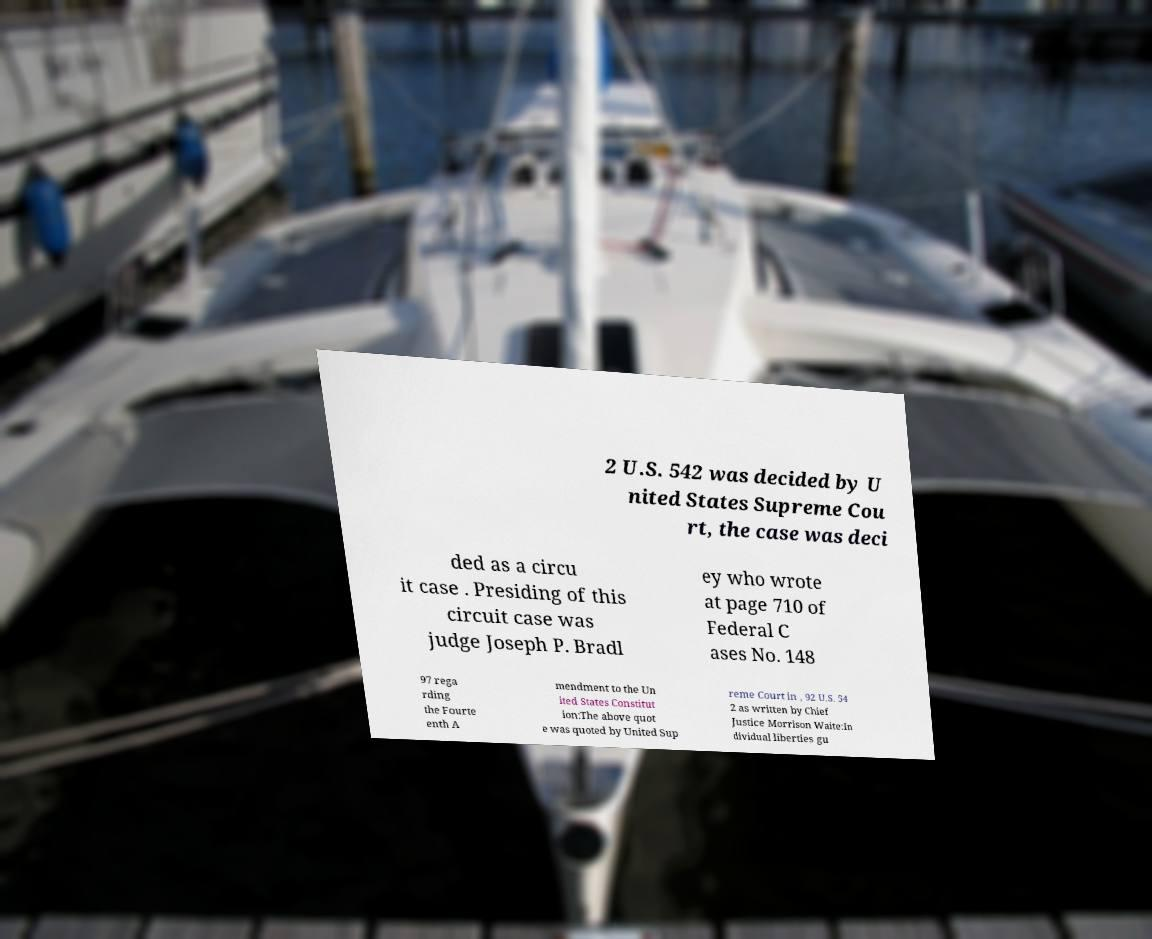What messages or text are displayed in this image? I need them in a readable, typed format. 2 U.S. 542 was decided by U nited States Supreme Cou rt, the case was deci ded as a circu it case . Presiding of this circuit case was judge Joseph P. Bradl ey who wrote at page 710 of Federal C ases No. 148 97 rega rding the Fourte enth A mendment to the Un ited States Constitut ion:The above quot e was quoted by United Sup reme Court in , 92 U.S. 54 2 as written by Chief Justice Morrison Waite:In dividual liberties gu 